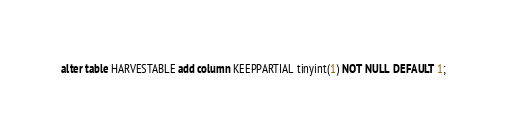Convert code to text. <code><loc_0><loc_0><loc_500><loc_500><_SQL_>alter table HARVESTABLE add column KEEPPARTIAL tinyint(1) NOT NULL DEFAULT 1;
</code> 